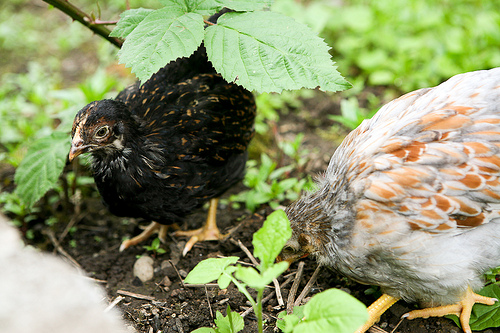<image>
Can you confirm if the animal is under the leaf? Yes. The animal is positioned underneath the leaf, with the leaf above it in the vertical space. 